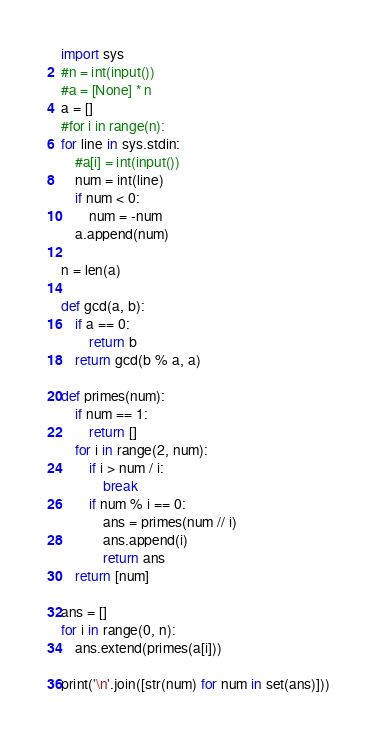Convert code to text. <code><loc_0><loc_0><loc_500><loc_500><_Python_>import sys
#n = int(input())
#a = [None] * n
a = []
#for i in range(n):
for line in sys.stdin:
    #a[i] = int(input())
    num = int(line)
    if num < 0:
        num = -num
    a.append(num)

n = len(a)

def gcd(a, b):
    if a == 0:
        return b
    return gcd(b % a, a)

def primes(num):
    if num == 1:
        return []
    for i in range(2, num):
        if i > num / i:
            break
        if num % i == 0:
            ans = primes(num // i)
            ans.append(i)
            return ans
    return [num]

ans = []
for i in range(0, n):
    ans.extend(primes(a[i]))

print('\n'.join([str(num) for num in set(ans)]))
</code> 